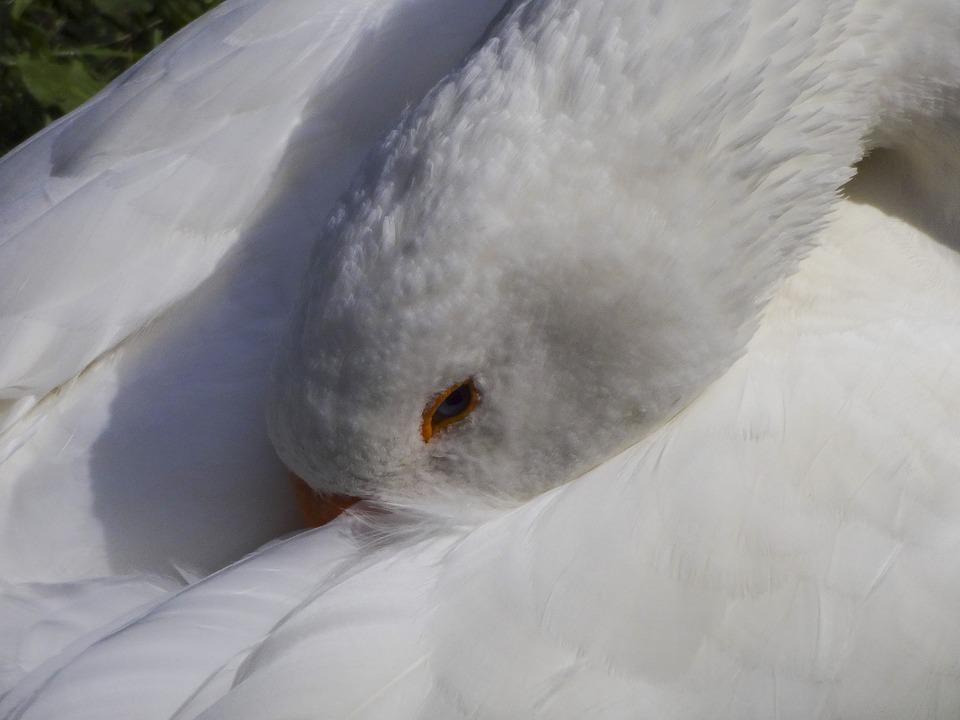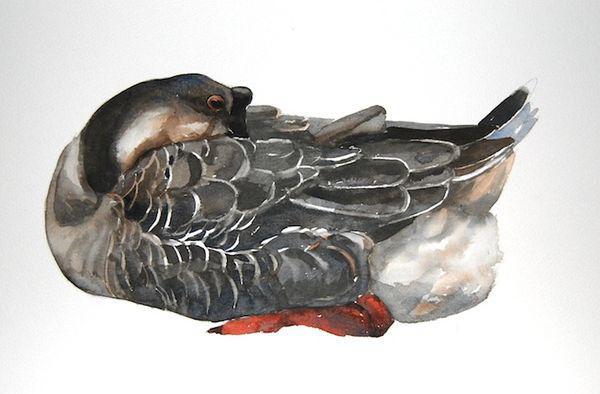The first image is the image on the left, the second image is the image on the right. Assess this claim about the two images: "A single bird has its head in its feathers.". Correct or not? Answer yes or no. Yes. The first image is the image on the left, the second image is the image on the right. Given the left and right images, does the statement "There are two birds in total." hold true? Answer yes or no. Yes. 